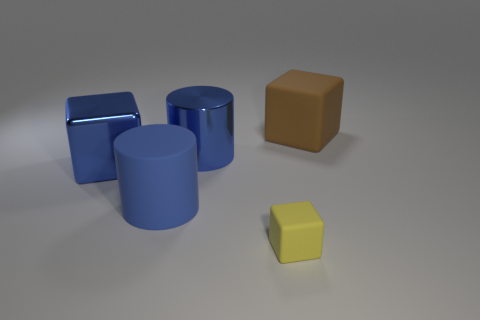There is a brown thing that is the same size as the blue matte object; what is its material?
Offer a terse response. Rubber. What number of objects are rubber things behind the small yellow thing or rubber cubes that are in front of the blue block?
Ensure brevity in your answer.  3. Is there a tiny yellow shiny object of the same shape as the brown matte object?
Give a very brief answer. No. What material is the other big cylinder that is the same color as the metallic cylinder?
Ensure brevity in your answer.  Rubber. What number of rubber things are either yellow cubes or big blue things?
Offer a very short reply. 2. What is the shape of the small yellow object?
Give a very brief answer. Cube. What number of tiny green balls are made of the same material as the small cube?
Make the answer very short. 0. What color is the big cylinder that is the same material as the yellow thing?
Give a very brief answer. Blue. There is a blue cylinder that is on the right side of the rubber cylinder; is it the same size as the tiny rubber cube?
Your response must be concise. No. What is the color of the big matte object that is the same shape as the small object?
Your answer should be compact. Brown. 